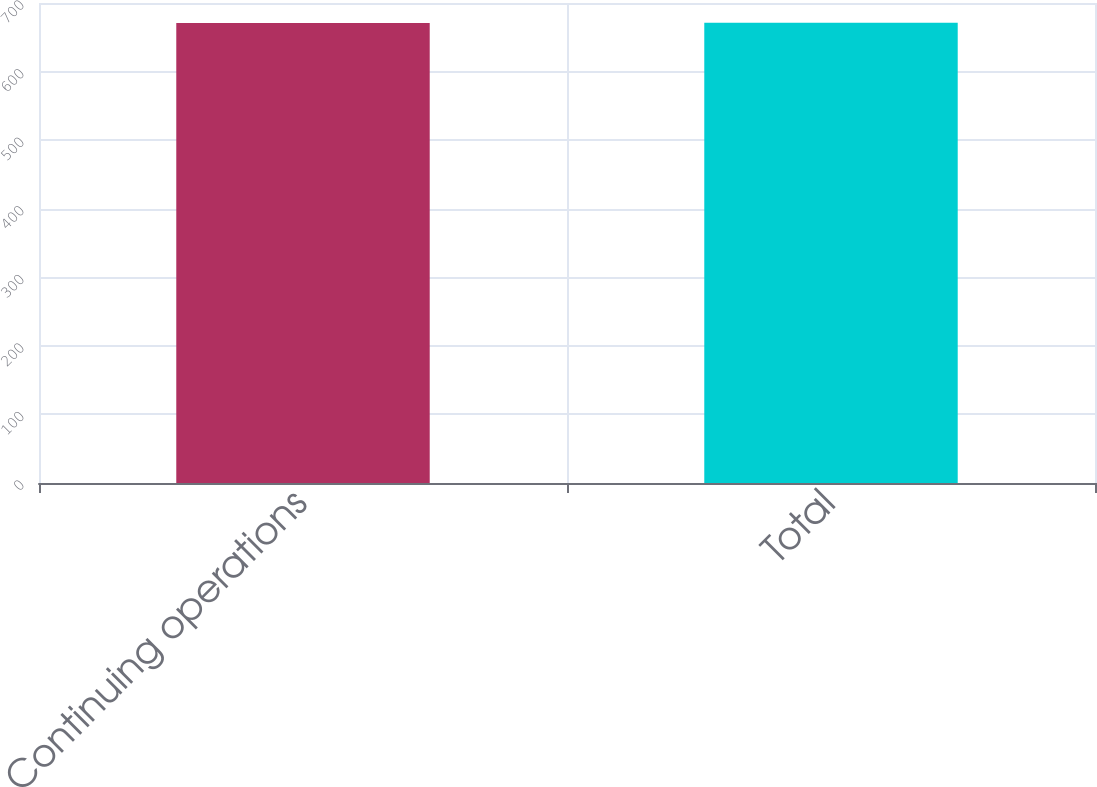Convert chart. <chart><loc_0><loc_0><loc_500><loc_500><bar_chart><fcel>Continuing operations<fcel>Total<nl><fcel>671<fcel>671.1<nl></chart> 